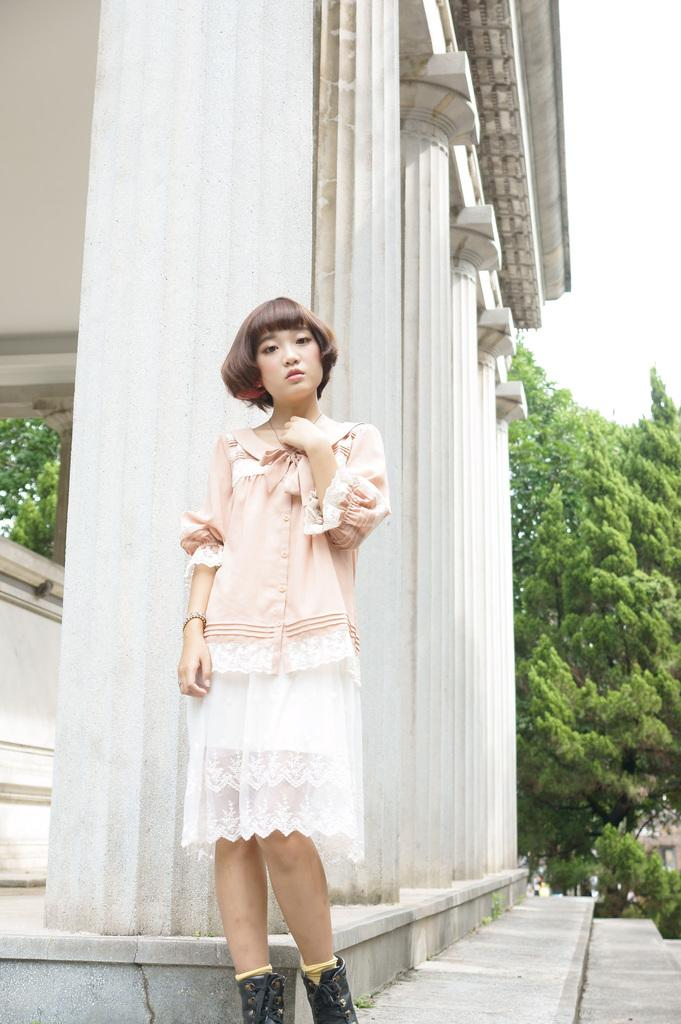What is the main subject of the image? The main subject of the image is a woman standing. What is the woman wearing in the image? The woman is wearing a top, a skirt, and shoes in the image. What type of structure can be seen in the image? The image appears to depict a building, as there are pillars present. What type of vegetation is visible in the image? There are trees with branches and leaves in the image. Can you see any ghosts interacting with the woman in the image? No, there are no ghosts present in the image. What type of stitch is used to create the pattern on the woman's skirt? The image does not provide enough detail to determine the type of stitch used on the woman's skirt. 